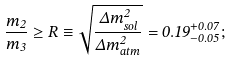Convert formula to latex. <formula><loc_0><loc_0><loc_500><loc_500>\frac { m _ { 2 } } { m _ { 3 } } \geq R \equiv \sqrt { \frac { \Delta m ^ { 2 } _ { s o l } } { \Delta m ^ { 2 } _ { a t m } } } = 0 . 1 9 ^ { + 0 . 0 7 } _ { - 0 . 0 5 } ;</formula> 